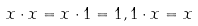Convert formula to latex. <formula><loc_0><loc_0><loc_500><loc_500>x \cdot x = x \cdot 1 = 1 , 1 \cdot x = x</formula> 